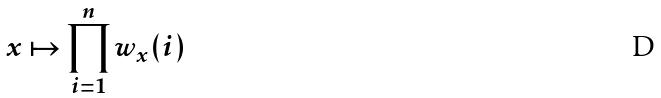Convert formula to latex. <formula><loc_0><loc_0><loc_500><loc_500>x \mapsto \prod _ { i = 1 } ^ { n } w _ { x } ( i )</formula> 